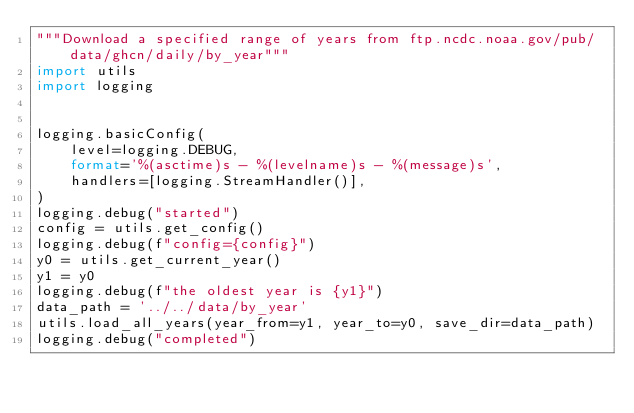Convert code to text. <code><loc_0><loc_0><loc_500><loc_500><_Python_>"""Download a specified range of years from ftp.ncdc.noaa.gov/pub/data/ghcn/daily/by_year"""
import utils
import logging


logging.basicConfig(
    level=logging.DEBUG,
    format='%(asctime)s - %(levelname)s - %(message)s',
    handlers=[logging.StreamHandler()],
)
logging.debug("started")
config = utils.get_config()
logging.debug(f"config={config}")
y0 = utils.get_current_year()
y1 = y0
logging.debug(f"the oldest year is {y1}")
data_path = '../../data/by_year'
utils.load_all_years(year_from=y1, year_to=y0, save_dir=data_path)
logging.debug("completed")
</code> 